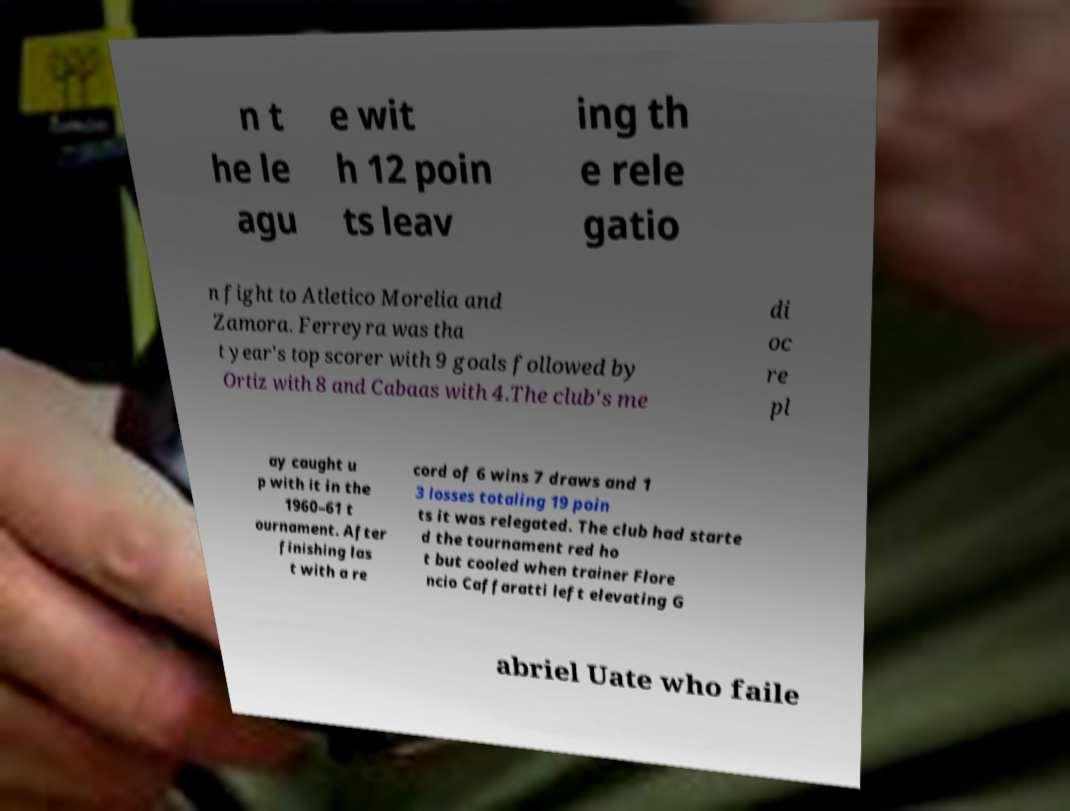I need the written content from this picture converted into text. Can you do that? n t he le agu e wit h 12 poin ts leav ing th e rele gatio n fight to Atletico Morelia and Zamora. Ferreyra was tha t year's top scorer with 9 goals followed by Ortiz with 8 and Cabaas with 4.The club's me di oc re pl ay caught u p with it in the 1960–61 t ournament. After finishing las t with a re cord of 6 wins 7 draws and 1 3 losses totaling 19 poin ts it was relegated. The club had starte d the tournament red ho t but cooled when trainer Flore ncio Caffaratti left elevating G abriel Uate who faile 